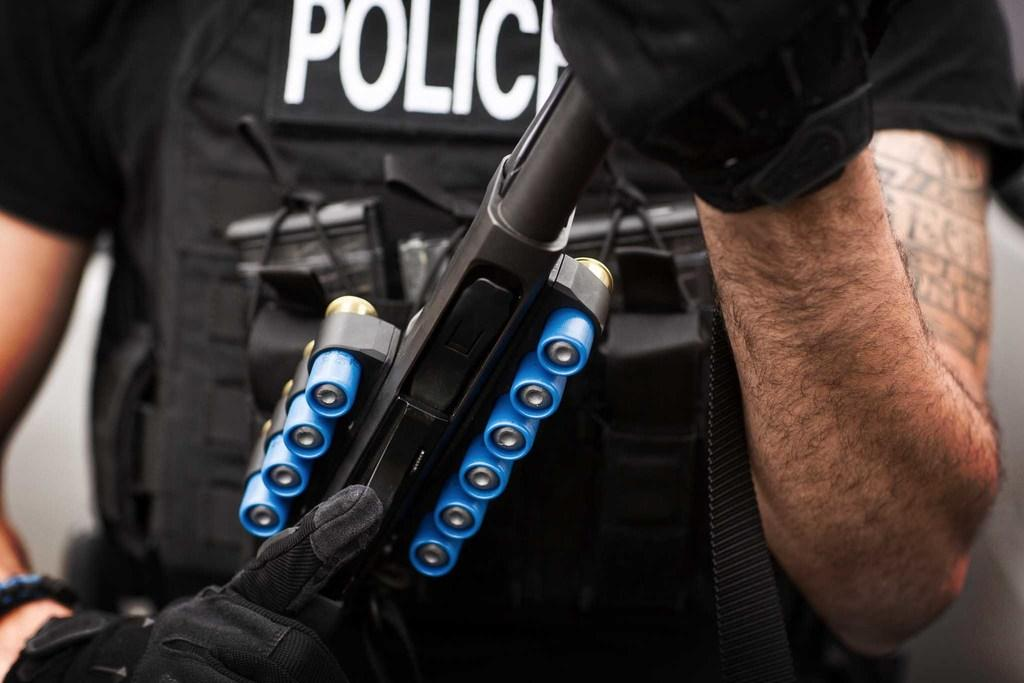What is the main subject of the image? There is a cop in the image. Where is the cop located in the image? The cop is in the center of the image. What is the cop holding in his hands? The cop is holding a gun in his hands. What type of ring can be seen on the cop's finger in the image? There is no ring visible on the cop's finger in the image. How many pickles are present in the image? There are no pickles present in the image. 